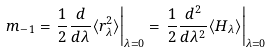Convert formula to latex. <formula><loc_0><loc_0><loc_500><loc_500>m _ { - 1 } = \left . \frac { 1 } { 2 } \frac { d } { d \lambda } \langle r ^ { 2 } _ { \lambda } \rangle \right | _ { \lambda = 0 } = \left . \frac { 1 } { 2 } \frac { d ^ { 2 } } { d \lambda ^ { 2 } } \langle H _ { \lambda } \rangle \right | _ { \lambda = 0 }</formula> 